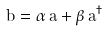Convert formula to latex. <formula><loc_0><loc_0><loc_500><loc_500>\hat { b } = \alpha \, \hat { a } + \beta \, \hat { a } ^ { \dagger }</formula> 